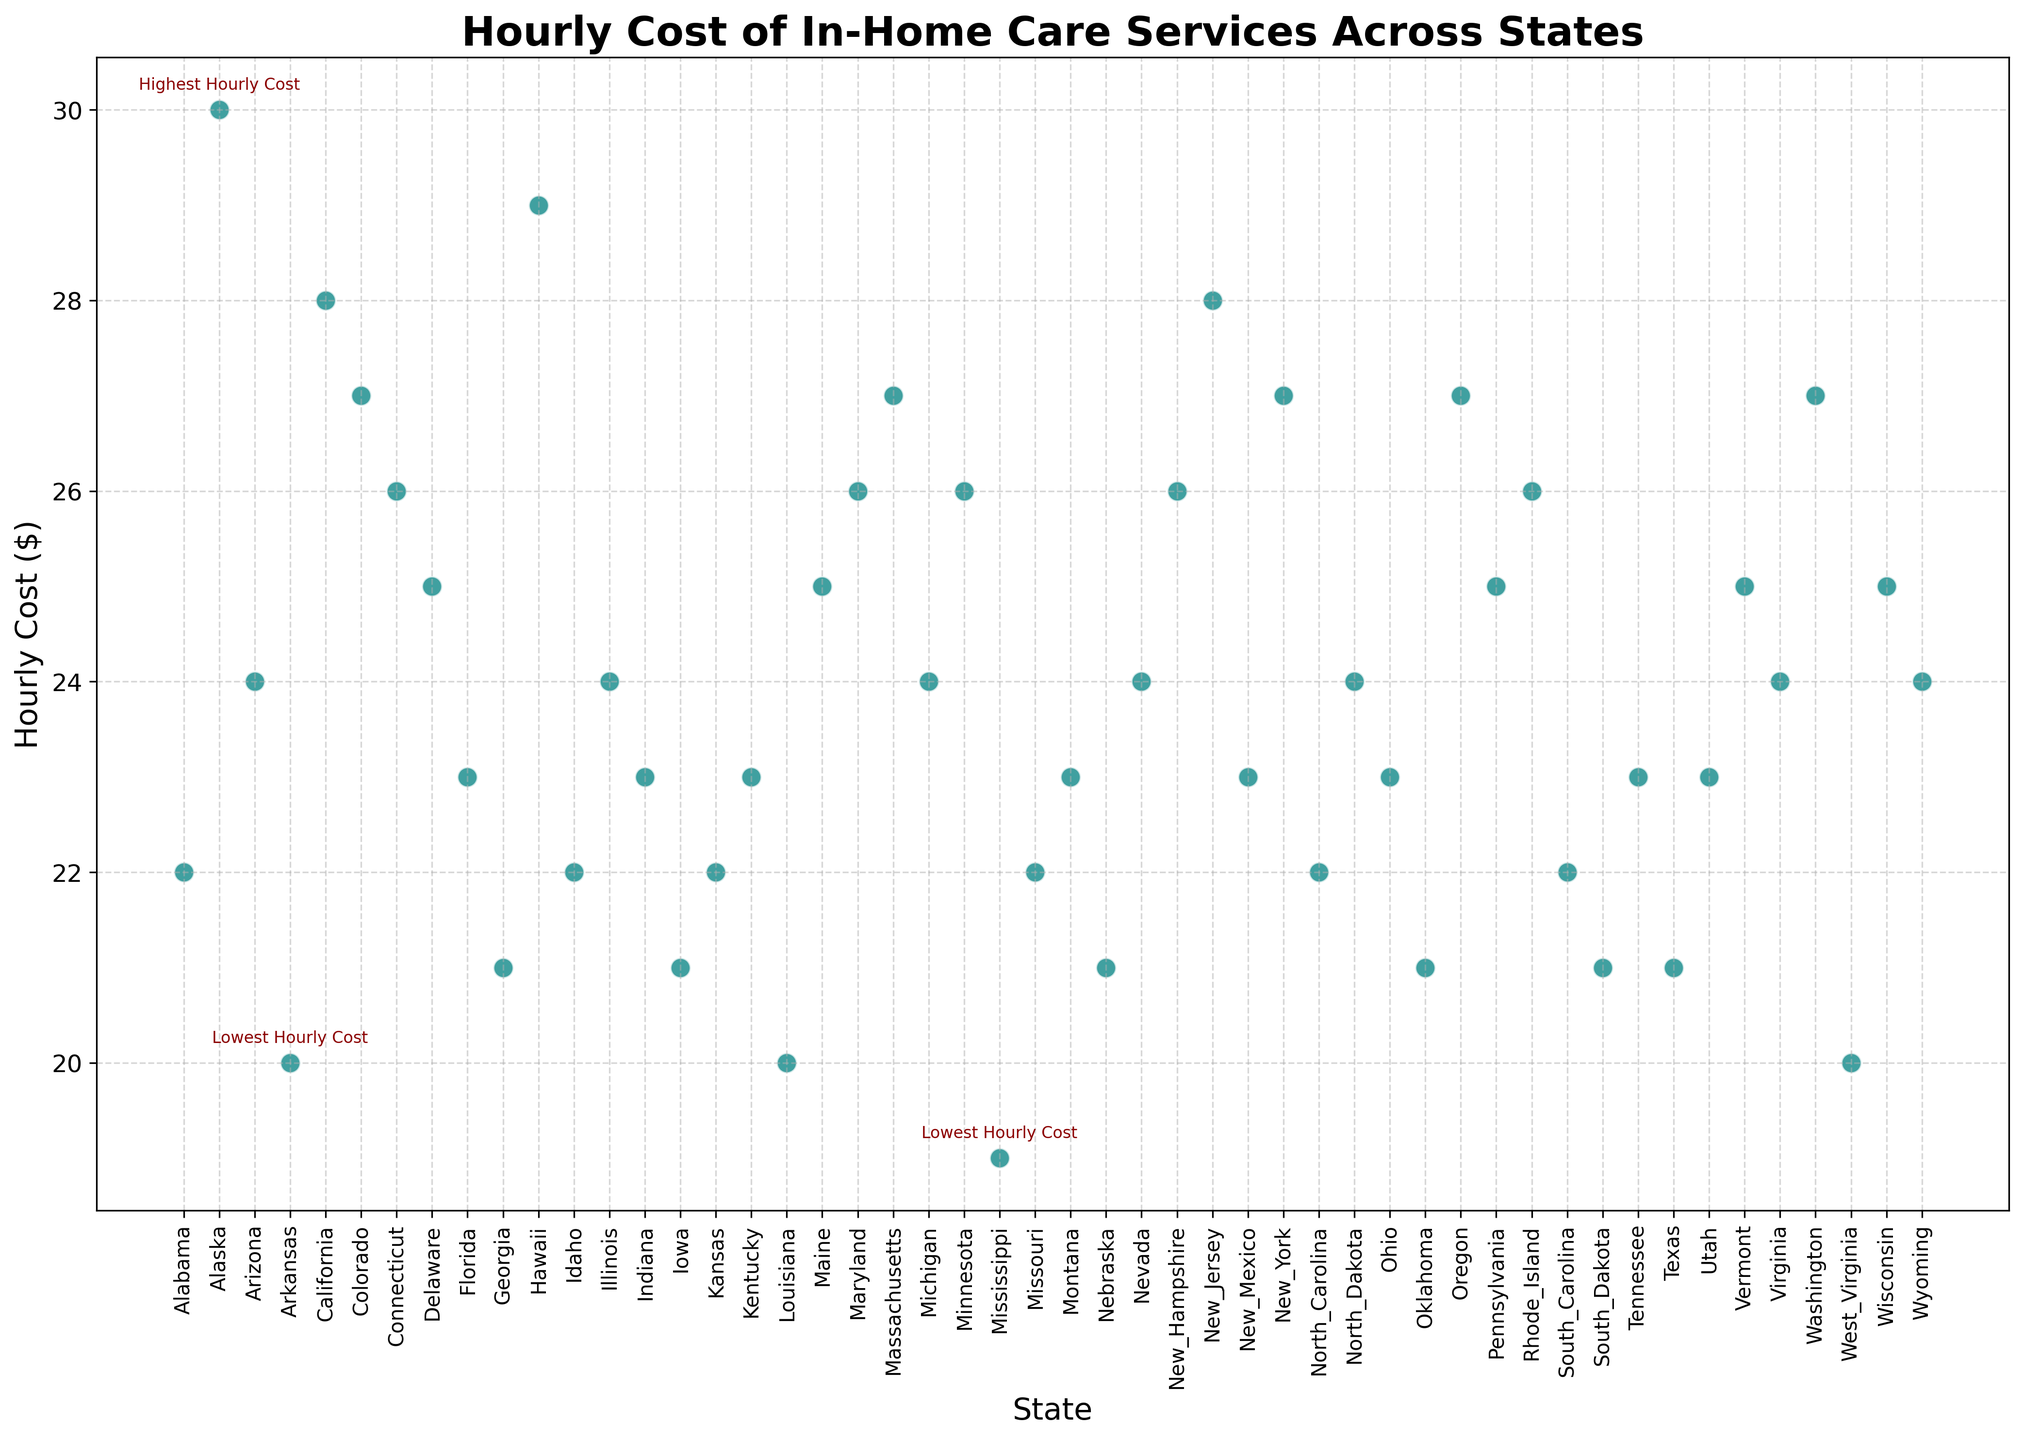What state has the highest hourly cost for in-home care services? The scatter plot has an annotation indicating the highest hourly cost. This annotation is present next to the data point representing Alaska with an hourly cost of $30.
Answer: Alaska Which state has the lowest hourly cost for in-home care services? The scatter plot includes annotations for the lowest hourly costs. These annotations are next to the data points for Arkansas and Mississippi, both marked with an hourly cost of $20.
Answer: Arkansas and Mississippi How does the hourly cost in California compare to that in Texas? Examine the y-values for California and Texas on the scatter plot. California has an hourly cost of $28, while Texas has an hourly cost of $21.
Answer: California's hourly cost is higher than Texas's What is the average hourly cost of in-home care services across all the states? Sum up all the hourly costs listed on the y-axis and divide by the number of states. The total sum is 1078, and there are 50 states. The average is 1078/50 = $21.56.
Answer: $21.56 Which states have an hourly cost lower than $23? Identify the data points where the y-value is less than $23 and list the corresponding states. This includes Alabama, Arkansas, Georgia, Iowa, Louisiana, Mississippi, Missouri, Nebraska, North Carolina, Oklahoma, South Dakota, Texas, and West Virginia.
Answer: Alabama, Arkansas, Georgia, Iowa, Louisiana, Mississippi, Missouri, Nebraska, North Carolina, Oklahoma, South Dakota, Texas, West Virginia What is the difference in the hourly cost between Hawaii and Idaho? Find the hourly costs of both states on the scatter plot. Hawaii has an hourly cost of $29 and Idaho has $22. The difference is 29 - 22 = $7.
Answer: $7 What are the annotations present in the scatter plot? Identify and list the text annotations present on the plot. These are next to the data points for Alaska and Arkansas, both indicating the highest and lowest hourly costs, respectively. Additionally, Mississippi is also annotated with the lowest hourly cost.
Answer: Highest Hourly Cost, Lowest Hourly Cost What is the hourly cost trend between the East Coast states (e.g., New York, New Jersey, Connecticut, Florida) and the West Coast states (e.g., California, Oregon, Washington)? Compare the scatter points for East Coast states' hourly costs and those of West Coast states. East Coast states like New York ($27), New Jersey ($28), Connecticut ($26), and Florida ($23) have mixed costs, while West Coast states California ($28), Oregon ($27), and Washington ($27) show consistently high costs.
Answer: East Coast varies, West Coast high and consistent 